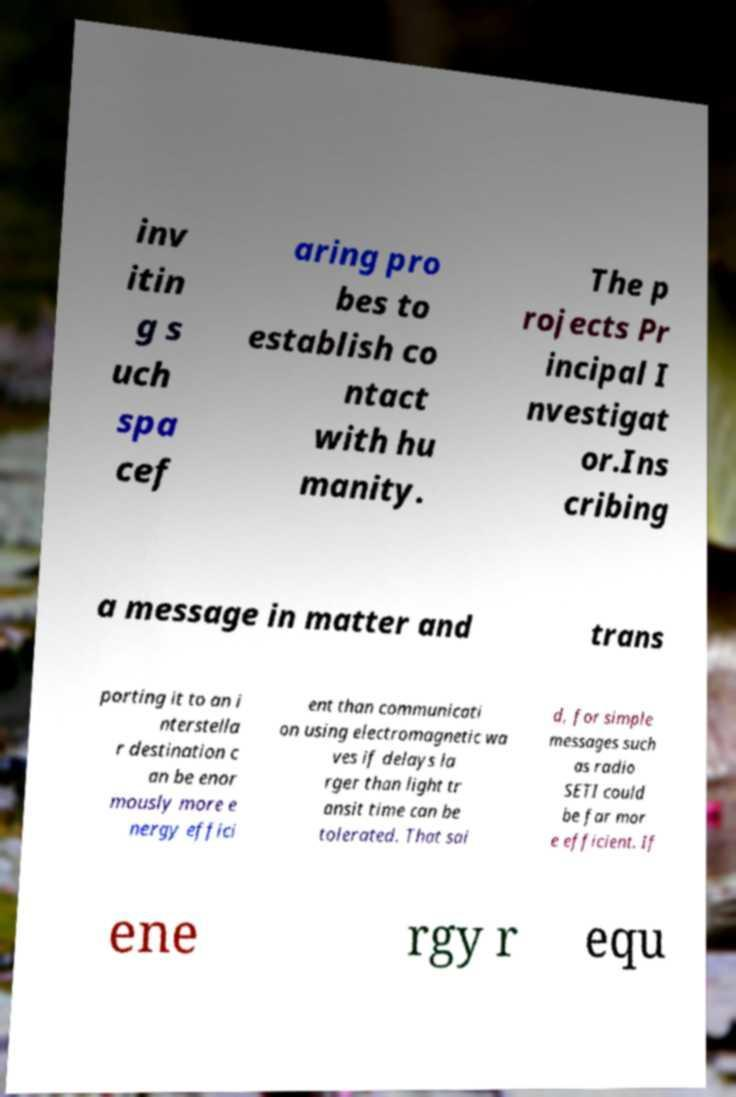I need the written content from this picture converted into text. Can you do that? inv itin g s uch spa cef aring pro bes to establish co ntact with hu manity. The p rojects Pr incipal I nvestigat or.Ins cribing a message in matter and trans porting it to an i nterstella r destination c an be enor mously more e nergy effici ent than communicati on using electromagnetic wa ves if delays la rger than light tr ansit time can be tolerated. That sai d, for simple messages such as radio SETI could be far mor e efficient. If ene rgy r equ 